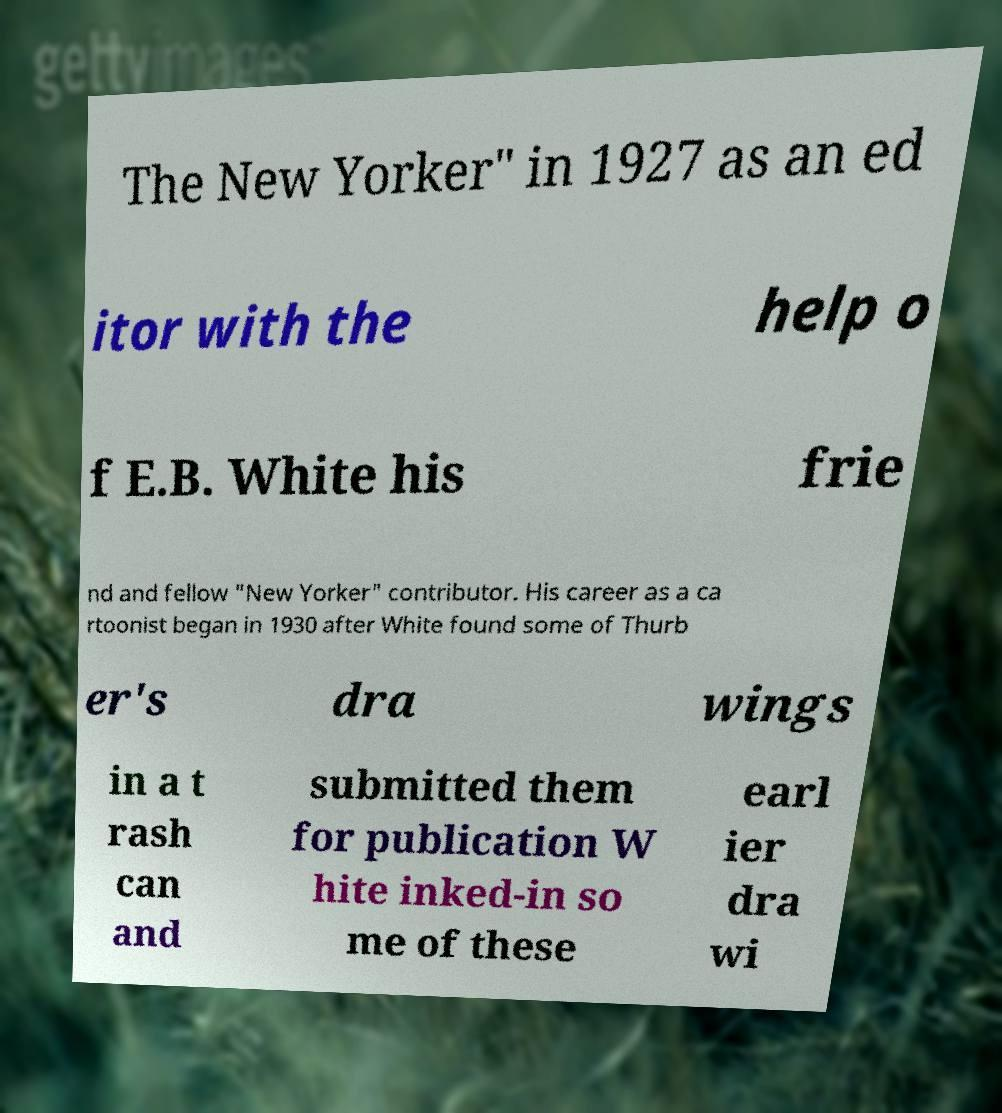There's text embedded in this image that I need extracted. Can you transcribe it verbatim? The New Yorker" in 1927 as an ed itor with the help o f E.B. White his frie nd and fellow "New Yorker" contributor. His career as a ca rtoonist began in 1930 after White found some of Thurb er's dra wings in a t rash can and submitted them for publication W hite inked-in so me of these earl ier dra wi 